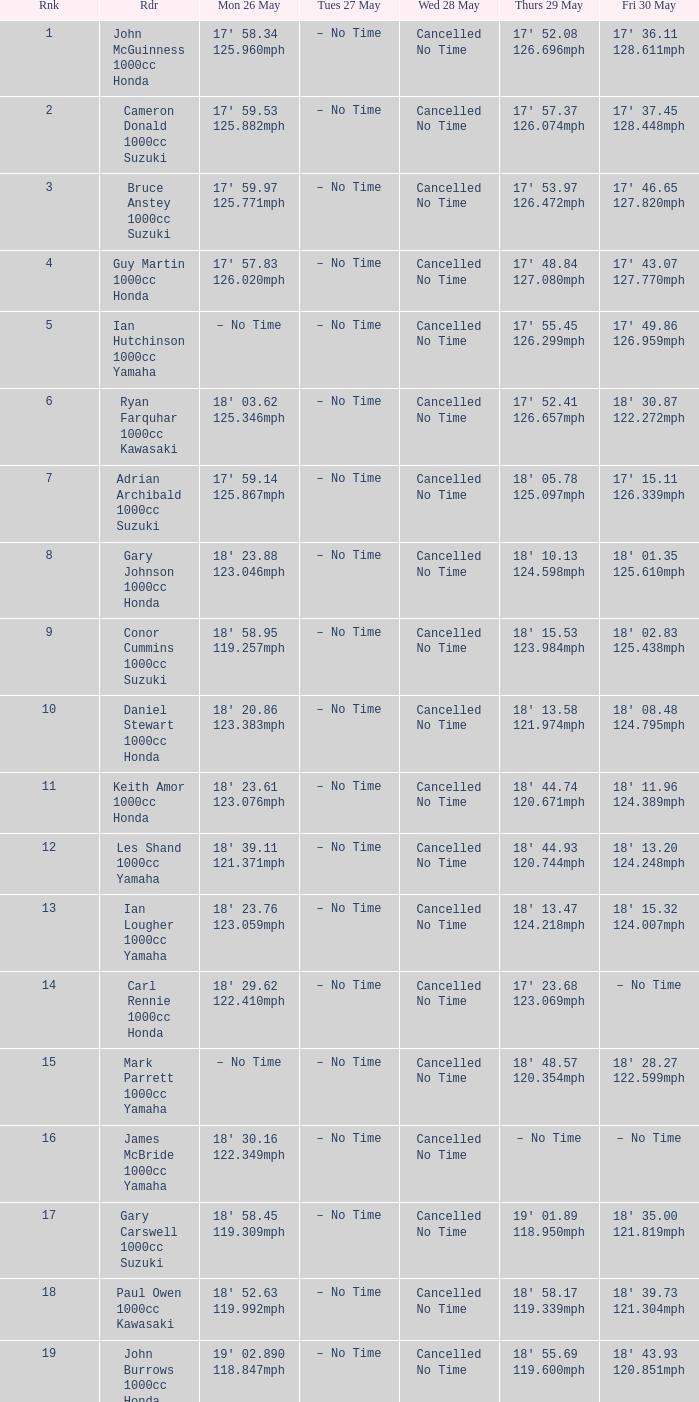What is the quantity for fri may 30 and mon may 26 is 19' 0 18' 43.93 120.851mph. 